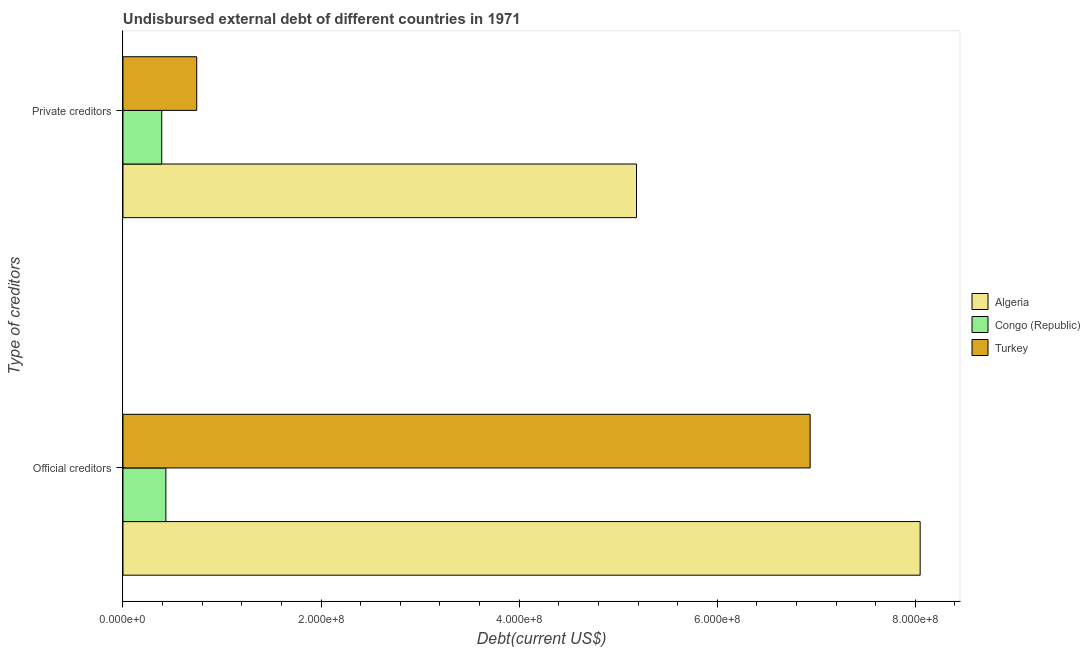How many different coloured bars are there?
Ensure brevity in your answer.  3. How many bars are there on the 2nd tick from the bottom?
Ensure brevity in your answer.  3. What is the label of the 2nd group of bars from the top?
Ensure brevity in your answer.  Official creditors. What is the undisbursed external debt of private creditors in Congo (Republic)?
Your answer should be very brief. 3.91e+07. Across all countries, what is the maximum undisbursed external debt of private creditors?
Ensure brevity in your answer.  5.18e+08. Across all countries, what is the minimum undisbursed external debt of official creditors?
Provide a short and direct response. 4.33e+07. In which country was the undisbursed external debt of private creditors maximum?
Give a very brief answer. Algeria. In which country was the undisbursed external debt of private creditors minimum?
Offer a very short reply. Congo (Republic). What is the total undisbursed external debt of official creditors in the graph?
Ensure brevity in your answer.  1.54e+09. What is the difference between the undisbursed external debt of official creditors in Turkey and that in Algeria?
Your response must be concise. -1.11e+08. What is the difference between the undisbursed external debt of private creditors in Congo (Republic) and the undisbursed external debt of official creditors in Algeria?
Offer a very short reply. -7.66e+08. What is the average undisbursed external debt of official creditors per country?
Make the answer very short. 5.14e+08. What is the difference between the undisbursed external debt of private creditors and undisbursed external debt of official creditors in Algeria?
Provide a short and direct response. -2.86e+08. What is the ratio of the undisbursed external debt of official creditors in Turkey to that in Congo (Republic)?
Give a very brief answer. 16.02. Is the undisbursed external debt of official creditors in Turkey less than that in Algeria?
Keep it short and to the point. Yes. What does the 2nd bar from the top in Private creditors represents?
Make the answer very short. Congo (Republic). What does the 2nd bar from the bottom in Official creditors represents?
Your response must be concise. Congo (Republic). How many bars are there?
Offer a very short reply. 6. How many countries are there in the graph?
Offer a very short reply. 3. Does the graph contain any zero values?
Provide a succinct answer. No. Does the graph contain grids?
Your answer should be compact. No. How are the legend labels stacked?
Make the answer very short. Vertical. What is the title of the graph?
Give a very brief answer. Undisbursed external debt of different countries in 1971. Does "Macao" appear as one of the legend labels in the graph?
Your answer should be very brief. No. What is the label or title of the X-axis?
Offer a very short reply. Debt(current US$). What is the label or title of the Y-axis?
Offer a terse response. Type of creditors. What is the Debt(current US$) in Algeria in Official creditors?
Offer a terse response. 8.05e+08. What is the Debt(current US$) of Congo (Republic) in Official creditors?
Your answer should be very brief. 4.33e+07. What is the Debt(current US$) in Turkey in Official creditors?
Ensure brevity in your answer.  6.94e+08. What is the Debt(current US$) in Algeria in Private creditors?
Your answer should be very brief. 5.18e+08. What is the Debt(current US$) in Congo (Republic) in Private creditors?
Ensure brevity in your answer.  3.91e+07. What is the Debt(current US$) in Turkey in Private creditors?
Your response must be concise. 7.44e+07. Across all Type of creditors, what is the maximum Debt(current US$) of Algeria?
Give a very brief answer. 8.05e+08. Across all Type of creditors, what is the maximum Debt(current US$) in Congo (Republic)?
Your answer should be very brief. 4.33e+07. Across all Type of creditors, what is the maximum Debt(current US$) of Turkey?
Make the answer very short. 6.94e+08. Across all Type of creditors, what is the minimum Debt(current US$) of Algeria?
Offer a terse response. 5.18e+08. Across all Type of creditors, what is the minimum Debt(current US$) of Congo (Republic)?
Your answer should be compact. 3.91e+07. Across all Type of creditors, what is the minimum Debt(current US$) in Turkey?
Ensure brevity in your answer.  7.44e+07. What is the total Debt(current US$) in Algeria in the graph?
Provide a succinct answer. 1.32e+09. What is the total Debt(current US$) of Congo (Republic) in the graph?
Your response must be concise. 8.24e+07. What is the total Debt(current US$) in Turkey in the graph?
Your response must be concise. 7.68e+08. What is the difference between the Debt(current US$) in Algeria in Official creditors and that in Private creditors?
Your answer should be very brief. 2.86e+08. What is the difference between the Debt(current US$) in Congo (Republic) in Official creditors and that in Private creditors?
Your response must be concise. 4.18e+06. What is the difference between the Debt(current US$) in Turkey in Official creditors and that in Private creditors?
Offer a very short reply. 6.19e+08. What is the difference between the Debt(current US$) in Algeria in Official creditors and the Debt(current US$) in Congo (Republic) in Private creditors?
Your answer should be very brief. 7.66e+08. What is the difference between the Debt(current US$) of Algeria in Official creditors and the Debt(current US$) of Turkey in Private creditors?
Your answer should be very brief. 7.30e+08. What is the difference between the Debt(current US$) in Congo (Republic) in Official creditors and the Debt(current US$) in Turkey in Private creditors?
Keep it short and to the point. -3.11e+07. What is the average Debt(current US$) in Algeria per Type of creditors?
Provide a short and direct response. 6.62e+08. What is the average Debt(current US$) of Congo (Republic) per Type of creditors?
Provide a succinct answer. 4.12e+07. What is the average Debt(current US$) in Turkey per Type of creditors?
Your answer should be compact. 3.84e+08. What is the difference between the Debt(current US$) of Algeria and Debt(current US$) of Congo (Republic) in Official creditors?
Offer a very short reply. 7.62e+08. What is the difference between the Debt(current US$) in Algeria and Debt(current US$) in Turkey in Official creditors?
Your answer should be very brief. 1.11e+08. What is the difference between the Debt(current US$) in Congo (Republic) and Debt(current US$) in Turkey in Official creditors?
Give a very brief answer. -6.50e+08. What is the difference between the Debt(current US$) in Algeria and Debt(current US$) in Congo (Republic) in Private creditors?
Your answer should be compact. 4.79e+08. What is the difference between the Debt(current US$) of Algeria and Debt(current US$) of Turkey in Private creditors?
Your answer should be compact. 4.44e+08. What is the difference between the Debt(current US$) in Congo (Republic) and Debt(current US$) in Turkey in Private creditors?
Your answer should be very brief. -3.53e+07. What is the ratio of the Debt(current US$) of Algeria in Official creditors to that in Private creditors?
Keep it short and to the point. 1.55. What is the ratio of the Debt(current US$) in Congo (Republic) in Official creditors to that in Private creditors?
Keep it short and to the point. 1.11. What is the ratio of the Debt(current US$) in Turkey in Official creditors to that in Private creditors?
Provide a short and direct response. 9.32. What is the difference between the highest and the second highest Debt(current US$) in Algeria?
Your response must be concise. 2.86e+08. What is the difference between the highest and the second highest Debt(current US$) in Congo (Republic)?
Your response must be concise. 4.18e+06. What is the difference between the highest and the second highest Debt(current US$) in Turkey?
Offer a very short reply. 6.19e+08. What is the difference between the highest and the lowest Debt(current US$) in Algeria?
Offer a very short reply. 2.86e+08. What is the difference between the highest and the lowest Debt(current US$) in Congo (Republic)?
Give a very brief answer. 4.18e+06. What is the difference between the highest and the lowest Debt(current US$) of Turkey?
Provide a short and direct response. 6.19e+08. 